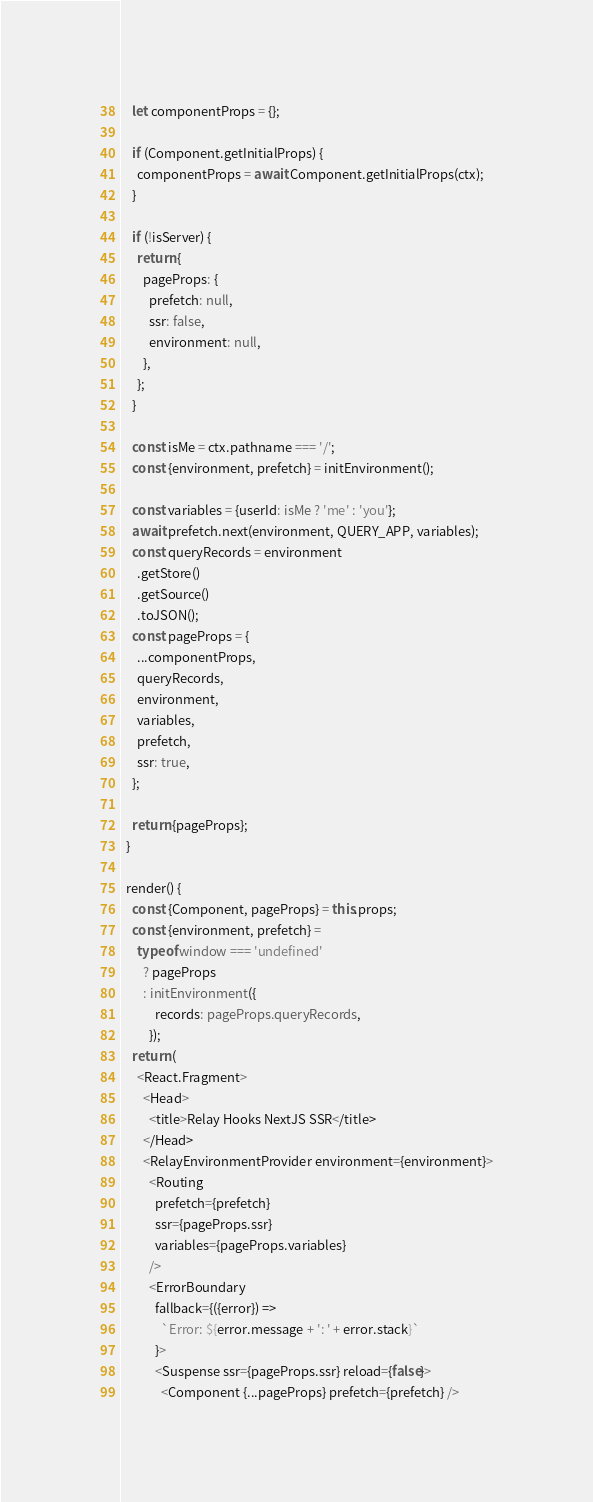<code> <loc_0><loc_0><loc_500><loc_500><_TypeScript_>    let componentProps = {};

    if (Component.getInitialProps) {
      componentProps = await Component.getInitialProps(ctx);
    }

    if (!isServer) {
      return {
        pageProps: {
          prefetch: null,
          ssr: false,
          environment: null,
        },
      };
    }

    const isMe = ctx.pathname === '/';
    const {environment, prefetch} = initEnvironment();

    const variables = {userId: isMe ? 'me' : 'you'};
    await prefetch.next(environment, QUERY_APP, variables);
    const queryRecords = environment
      .getStore()
      .getSource()
      .toJSON();
    const pageProps = {
      ...componentProps,
      queryRecords,
      environment,
      variables,
      prefetch,
      ssr: true,
    };

    return {pageProps};
  }

  render() {
    const {Component, pageProps} = this.props;
    const {environment, prefetch} =
      typeof window === 'undefined'
        ? pageProps
        : initEnvironment({
            records: pageProps.queryRecords,
          });
    return (
      <React.Fragment>
        <Head>
          <title>Relay Hooks NextJS SSR</title>
        </Head>
        <RelayEnvironmentProvider environment={environment}>
          <Routing
            prefetch={prefetch}
            ssr={pageProps.ssr}
            variables={pageProps.variables}
          />
          <ErrorBoundary
            fallback={({error}) =>
              `Error: ${error.message + ': ' + error.stack}`
            }>
            <Suspense ssr={pageProps.ssr} reload={false}>
              <Component {...pageProps} prefetch={prefetch} /></code> 